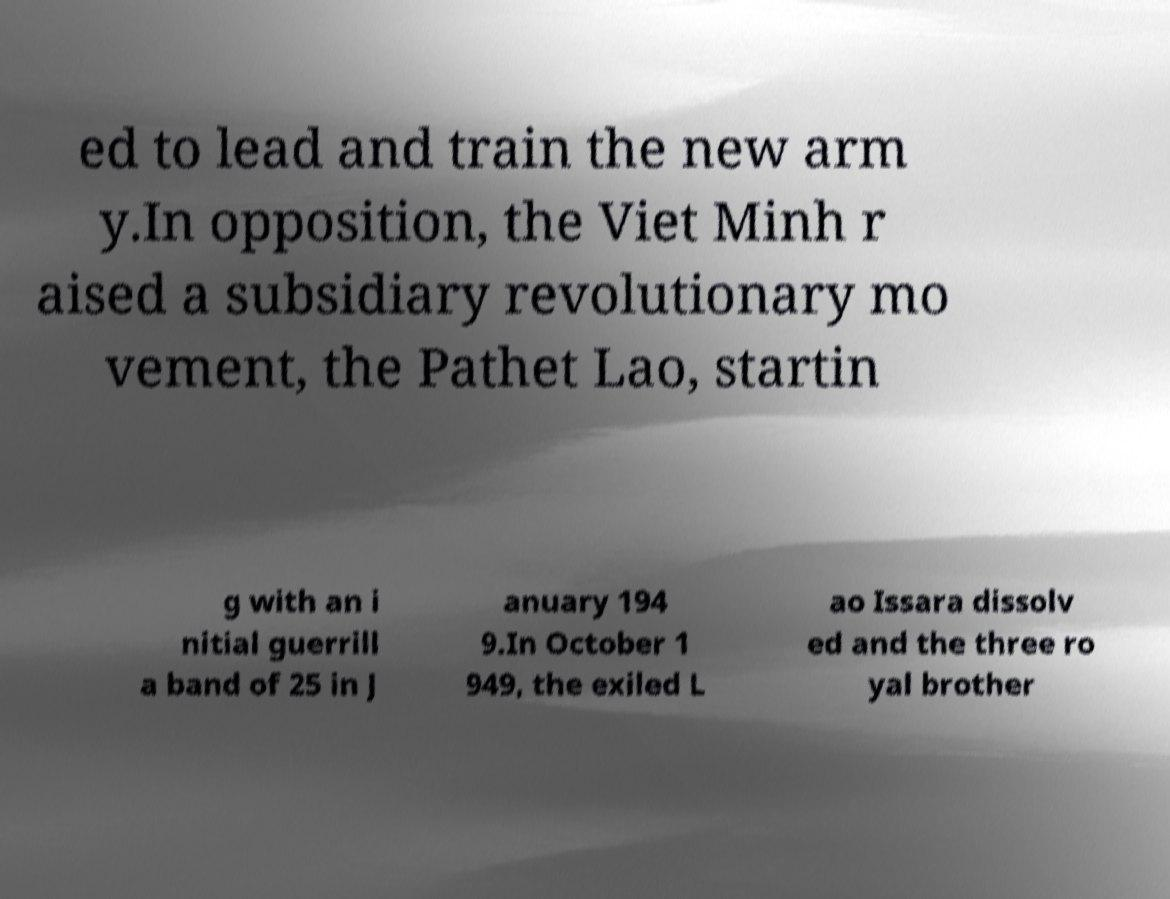Could you extract and type out the text from this image? ed to lead and train the new arm y.In opposition, the Viet Minh r aised a subsidiary revolutionary mo vement, the Pathet Lao, startin g with an i nitial guerrill a band of 25 in J anuary 194 9.In October 1 949, the exiled L ao Issara dissolv ed and the three ro yal brother 